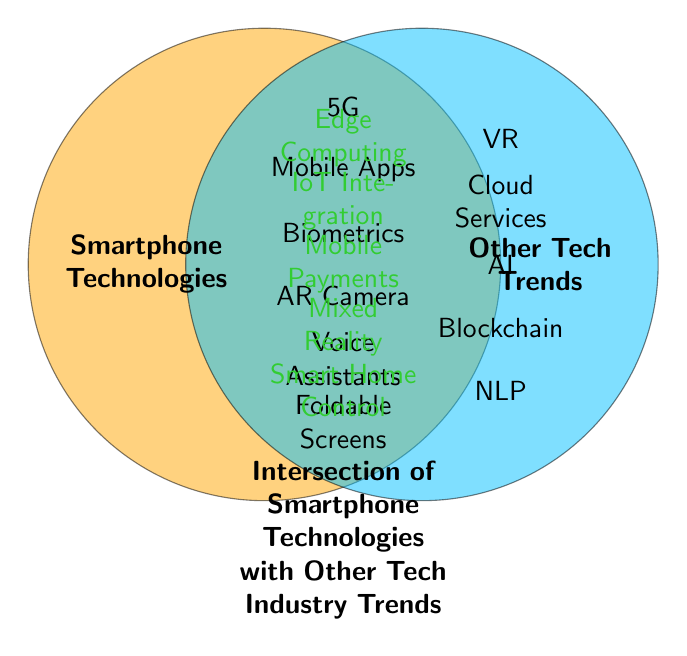What are two smartphone technologies listed in the figure? Look at the circle labeled "Smartphone Technologies" on the left. Choose any two items within this circle. Examples are "5G" and "Mobile Apps".
Answer: 5G, Mobile Apps Which technology trend appears in both smartphone and other tech trends circles? Identify elements that are placed in the overlapping section between the two circles, marked by their green color. Examples include "Edge Computing" and "IoT Integration".
Answer: Edge Computing, IoT Integration How many items are listed under other tech trends excluding intersections? Count the number of items in the circle labeled "Other Tech Trends" minus the items in the overlap, which are marked green.
Answer: 5 Which handset feature intersects with blockchain technologies? Find elements listed in the intersections section and correlate with "Blockchain" listed outside in other tech trends. Here, "Mobile Payments" correlates.
Answer: Mobile Payments What smartphone technology intersects with wearable tech trends? From the "Wearables" in other tech trends, locate items in the intersection section to find any related smartphone technology. "Flexible Displays" as seen relates.
Answer: Flexible Displays What are three intersections seen in the figure? Check the overlapping area, which is marked in green, and list three elements. Some examples are "Edge Computing," "IoT Integration", and "Smart Home Control".
Answer: Edge Computing, IoT Integration, Smart Home Control What tech trend combines voice assistants and smart home features? Consult the intersection section for shared items aligning with both "Voice Assistants" and "Smart Home Control".
Answer: Smart Home Control How many unique tech trends intersect with smartphone technologies? Count items within the intersection section in green color.
Answer: 5 Name one example of mixed reality from the intersection Mixed Reality is explicitly written in the overlap section, relating AR Cameras and VR.
Answer: Mixed Reality What proportion of smartphone technologies intersect with other tech trends? Total distinct items in the "Smartphone Technologies" circle are 6. Shared items in the intersection (5 green). Complete: 5/6.
Answer: 5/6 